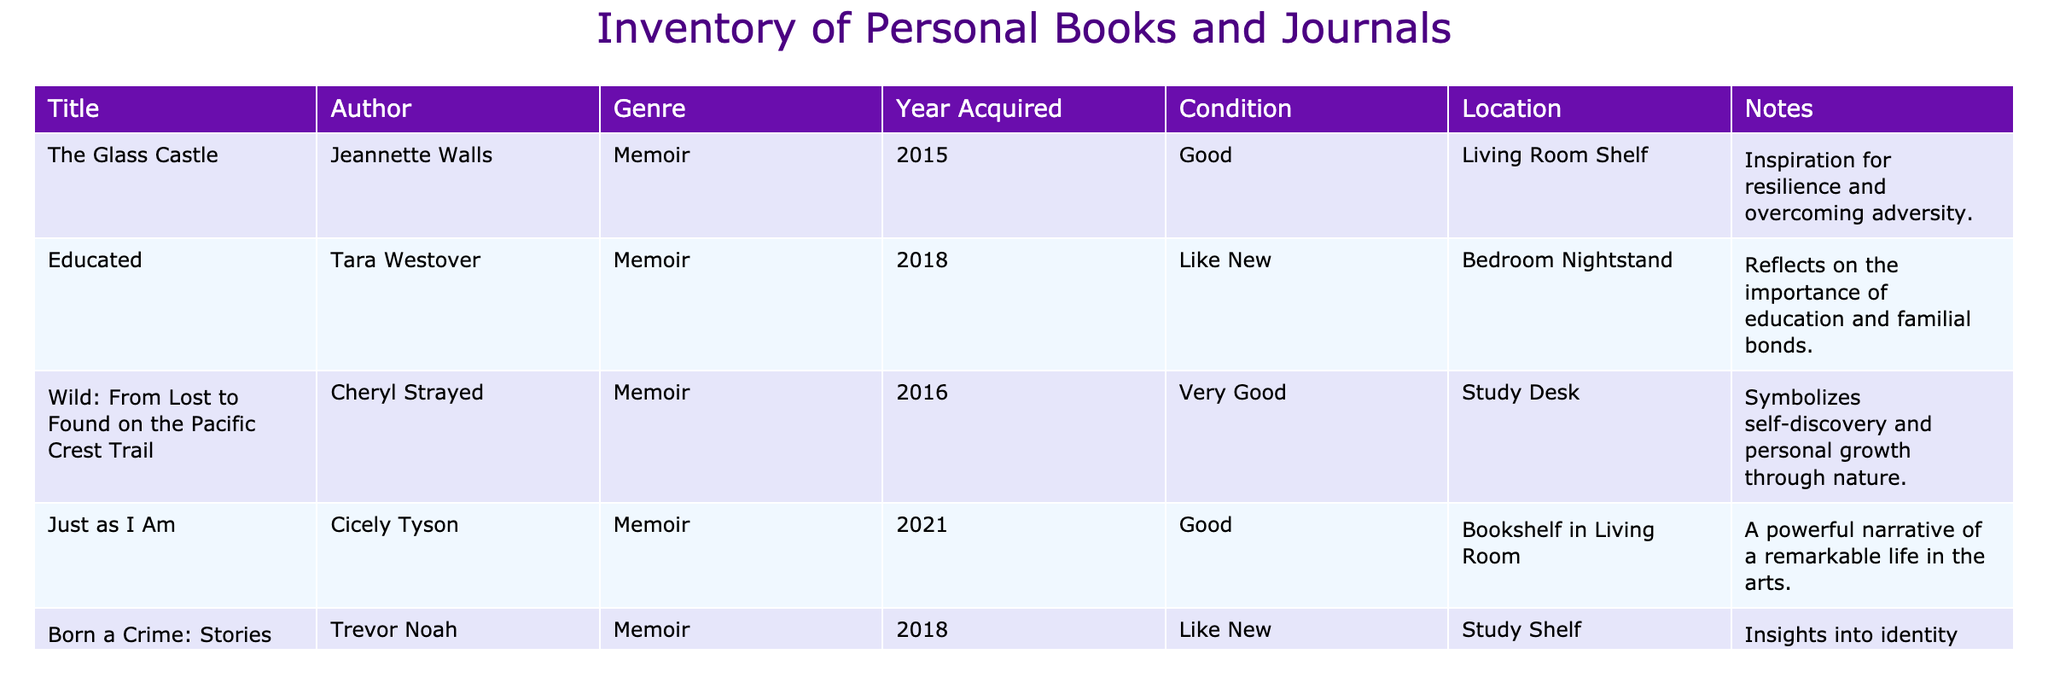What is the title of the book acquired in 2021? To find the title of the book acquired in 2021, we scan the "Year Acquired" column for the value 2021, which corresponds to "Just as I Am".
Answer: Just as I Am Which author's memoir reflects on the importance of education? We look for memoirs in the "Author" column that mention education in their "Notes". The record for "Educated" by Tara Westover specifically mentions the importance of education.
Answer: Tara Westover Is "Born a Crime: Stories from a South African Childhood" in very good condition? We find "Born a Crime: Stories from a South African Childhood" in the table and check its "Condition". It is listed as "Like New", which means it is not in very good condition.
Answer: No How many memoirs were acquired before 2018? We check the "Year Acquired" column for values less than 2018. "The Glass Castle" (2015), "Wild: From Lost to Found on the Pacific Crest Trail" (2016), and "Born a Crime: Stories from a South African Childhood" (2018) count as two memoirs acquired (in 2015 and 2016).
Answer: 2 What is the average acquisition year for the books listed? The acquisition years are 2015, 2016, 2018, 2018, and 2021. We sum these years (2015 + 2016 + 2018 + 2018 + 2021 = 10088) and divide by 5 to find the average: 10088 / 5 = 2017.6. Rounding gives an average year of 2018.
Answer: 2018 Which book on the shelf in the living room is classified as a memoir? We check the "Location" column for entries that include "Living Room Shelf", where we find "The Glass Castle" and "Just as I Am", both of which are memoirs.
Answer: The Glass Castle, Just as I Am What genre does "Wild: From Lost to Found on the Pacific Crest Trail" belong to? We look at the row for "Wild: From Lost to Found on the Pacific Crest Trail" and refer to the "Genre" column, where it is categorized as "Memoir".
Answer: Memoir Is "Just as I Am" written by a female author? We check the "Author" for "Just as I Am" and see that it is authored by Cicely Tyson, who is a female writer.
Answer: Yes Which book symbolizes self-discovery and personal growth? The "Notes" section shows that "Wild: From Lost to Found on the Pacific Crest Trail" is described as symbolizing self-discovery and personal growth.
Answer: Wild: From Lost to Found on the Pacific Crest Trail 